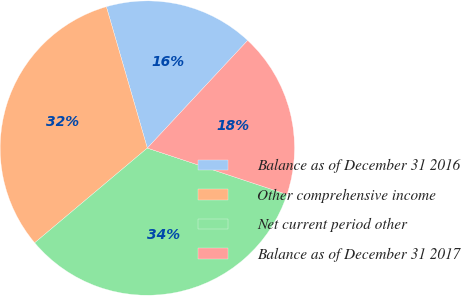Convert chart. <chart><loc_0><loc_0><loc_500><loc_500><pie_chart><fcel>Balance as of December 31 2016<fcel>Other comprehensive income<fcel>Net current period other<fcel>Balance as of December 31 2017<nl><fcel>16.43%<fcel>31.64%<fcel>33.77%<fcel>18.16%<nl></chart> 